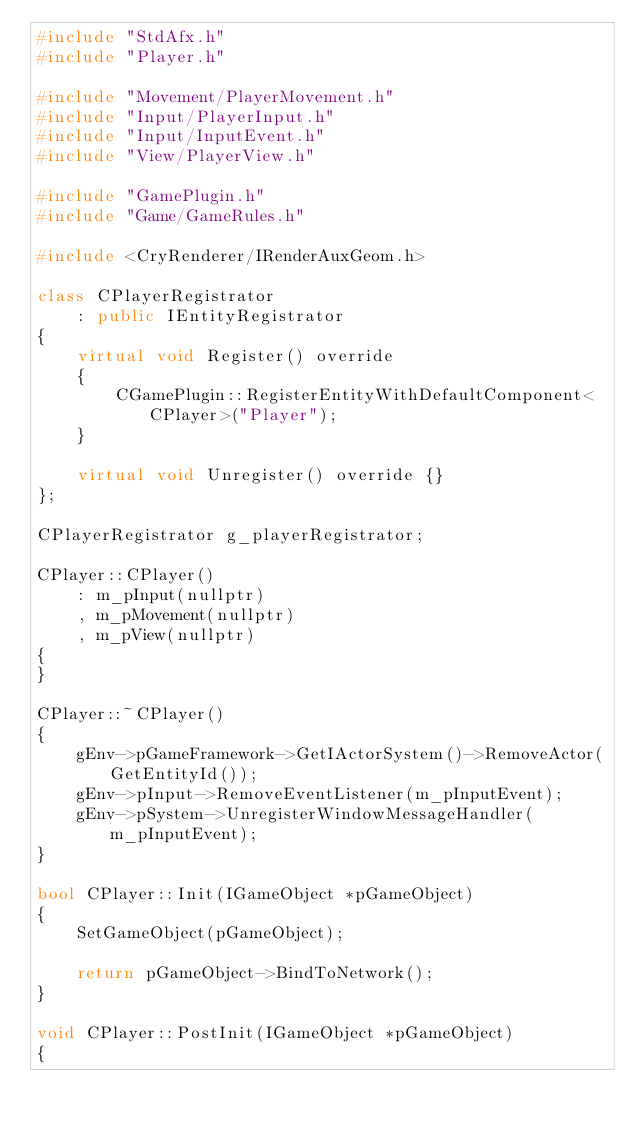<code> <loc_0><loc_0><loc_500><loc_500><_C++_>#include "StdAfx.h"
#include "Player.h"

#include "Movement/PlayerMovement.h"
#include "Input/PlayerInput.h"
#include "Input/InputEvent.h"
#include "View/PlayerView.h"

#include "GamePlugin.h"
#include "Game/GameRules.h"

#include <CryRenderer/IRenderAuxGeom.h>

class CPlayerRegistrator
	: public IEntityRegistrator
{
	virtual void Register() override
	{
		CGamePlugin::RegisterEntityWithDefaultComponent<CPlayer>("Player");
	}

	virtual void Unregister() override {}
};

CPlayerRegistrator g_playerRegistrator;

CPlayer::CPlayer()
	: m_pInput(nullptr)
	, m_pMovement(nullptr)
	, m_pView(nullptr)
{
}

CPlayer::~CPlayer()
{
	gEnv->pGameFramework->GetIActorSystem()->RemoveActor(GetEntityId());
	gEnv->pInput->RemoveEventListener(m_pInputEvent);
	gEnv->pSystem->UnregisterWindowMessageHandler(m_pInputEvent);
}

bool CPlayer::Init(IGameObject *pGameObject)
{
	SetGameObject(pGameObject);

	return pGameObject->BindToNetwork();
}

void CPlayer::PostInit(IGameObject *pGameObject)
{</code> 